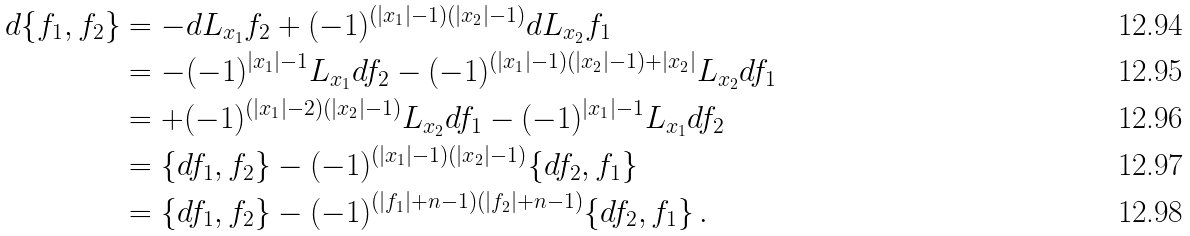<formula> <loc_0><loc_0><loc_500><loc_500>d \{ f _ { 1 } , f _ { 2 } \} & = - d L _ { x _ { 1 } } f _ { 2 } + ( - 1 ) ^ { ( | x _ { 1 } | - 1 ) ( | x _ { 2 } | - 1 ) } d L _ { x _ { 2 } } f _ { 1 } \\ & = - ( - 1 ) ^ { | x _ { 1 } | - 1 } L _ { x _ { 1 } } d f _ { 2 } - ( - 1 ) ^ { ( | x _ { 1 } | - 1 ) ( | x _ { 2 } | - 1 ) + | x _ { 2 } | } L _ { x _ { 2 } } d f _ { 1 } \\ & = + ( - 1 ) ^ { ( | x _ { 1 } | - 2 ) ( | x _ { 2 } | - 1 ) } L _ { x _ { 2 } } d f _ { 1 } - ( - 1 ) ^ { | x _ { 1 } | - 1 } L _ { x _ { 1 } } d f _ { 2 } \\ & = \{ d f _ { 1 } , f _ { 2 } \} - ( - 1 ) ^ { ( | x _ { 1 } | - 1 ) ( | x _ { 2 } | - 1 ) } \{ d f _ { 2 } , f _ { 1 } \} \\ & = \{ d f _ { 1 } , f _ { 2 } \} - ( - 1 ) ^ { ( | f _ { 1 } | + n - 1 ) ( | f _ { 2 } | + n - 1 ) } \{ d f _ { 2 } , f _ { 1 } \} \, .</formula> 